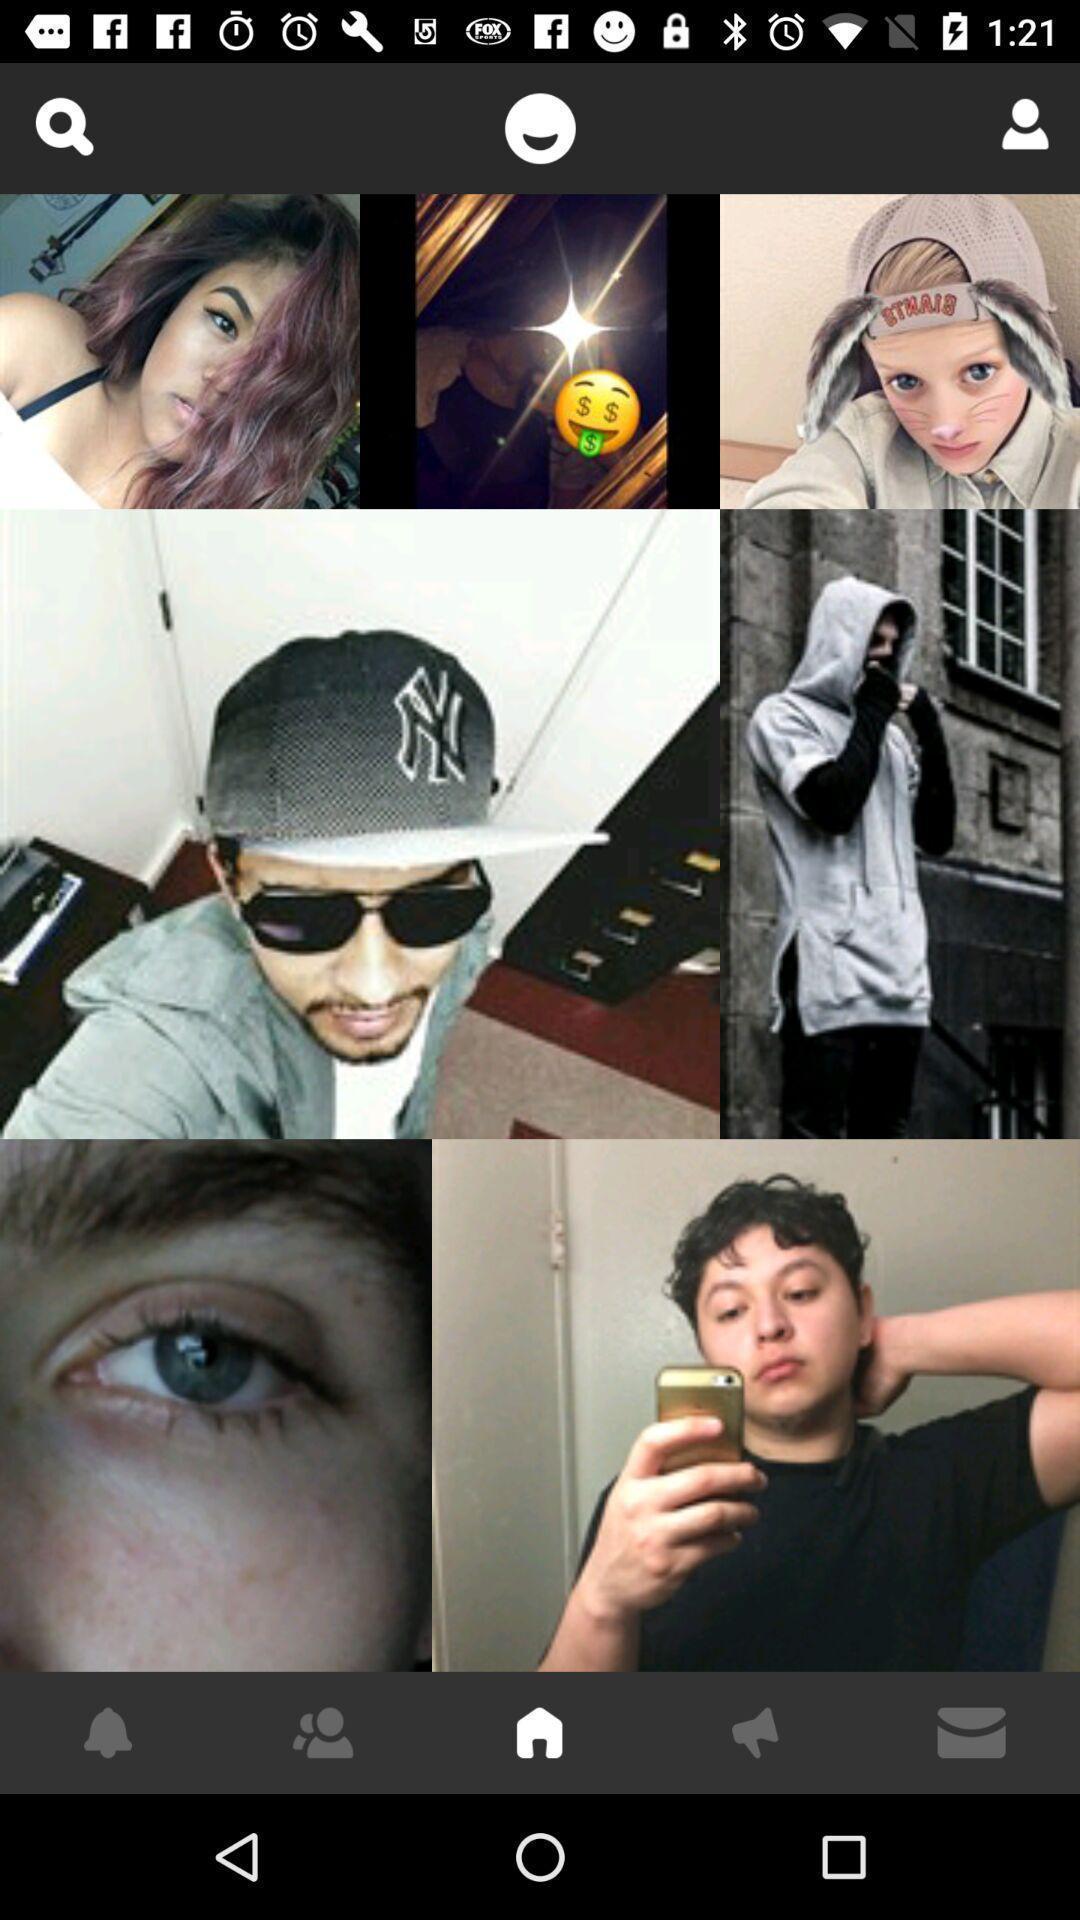Provide a textual representation of this image. Pictures of people are displaying on social app. 